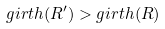Convert formula to latex. <formula><loc_0><loc_0><loc_500><loc_500>g i r t h ( R ^ { \prime } ) > g i r t h ( R )</formula> 